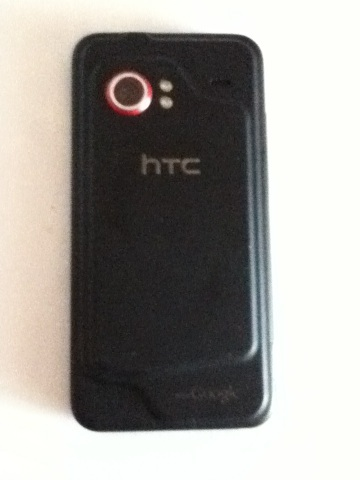Can you tell me more about the design features of this phone? Certainly! The phone in the image features a classic smartphone design with a particular focus on minimalism. It has a sleek black case with what appears to be a soft-touch finish for better grip. One notable design feature is the red accent around the camera lens, which adds a pop of color and might be indicative of an older HTC model, likely appealing to a design-conscious user when it was released. Additionally, the HTC logo is visible on the back, centrally positioned. 